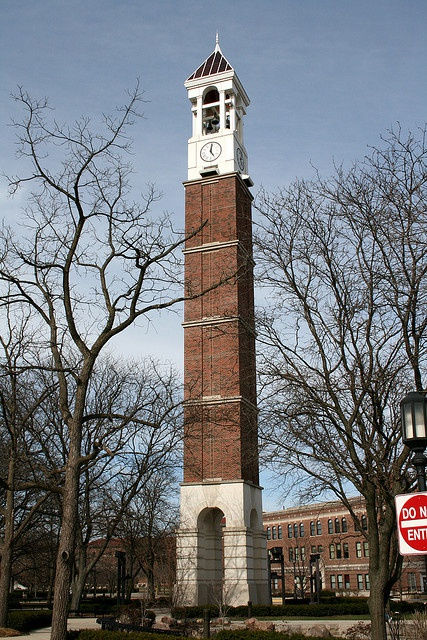Describe the objects in this image and their specific colors. I can see clock in gray, white, and darkgray tones and clock in gray and black tones in this image. 